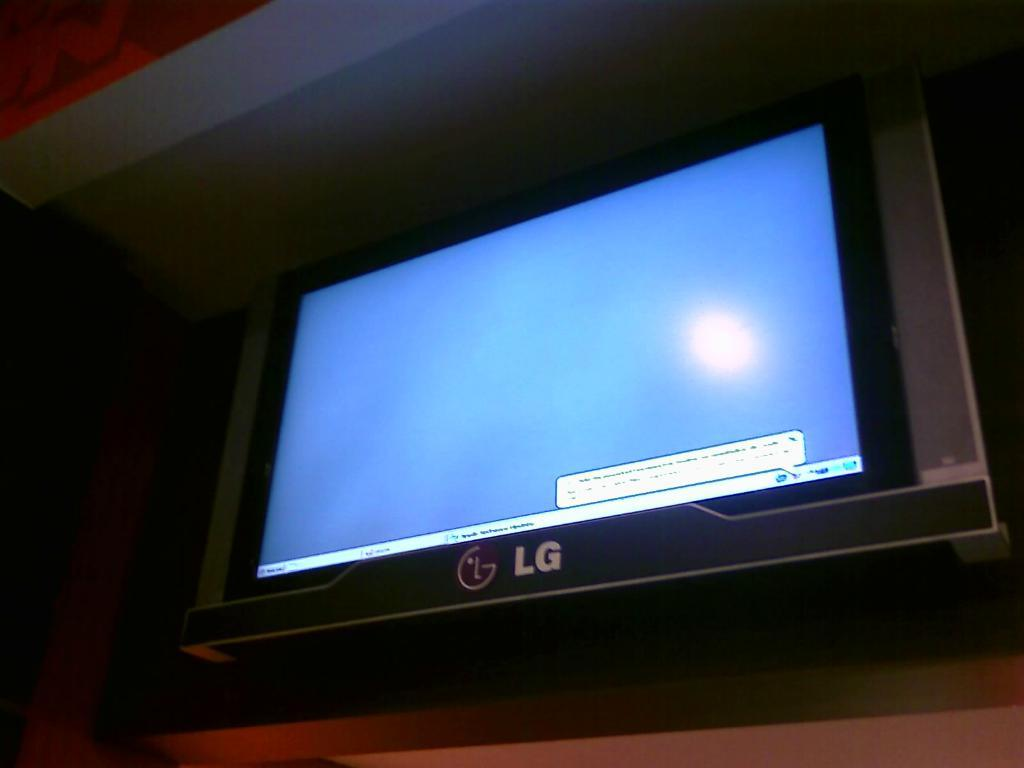<image>
Render a clear and concise summary of the photo. An LG computer screen with a warning in the lower right corner. 